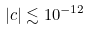<formula> <loc_0><loc_0><loc_500><loc_500>| c | \lesssim 1 0 ^ { - 1 2 }</formula> 